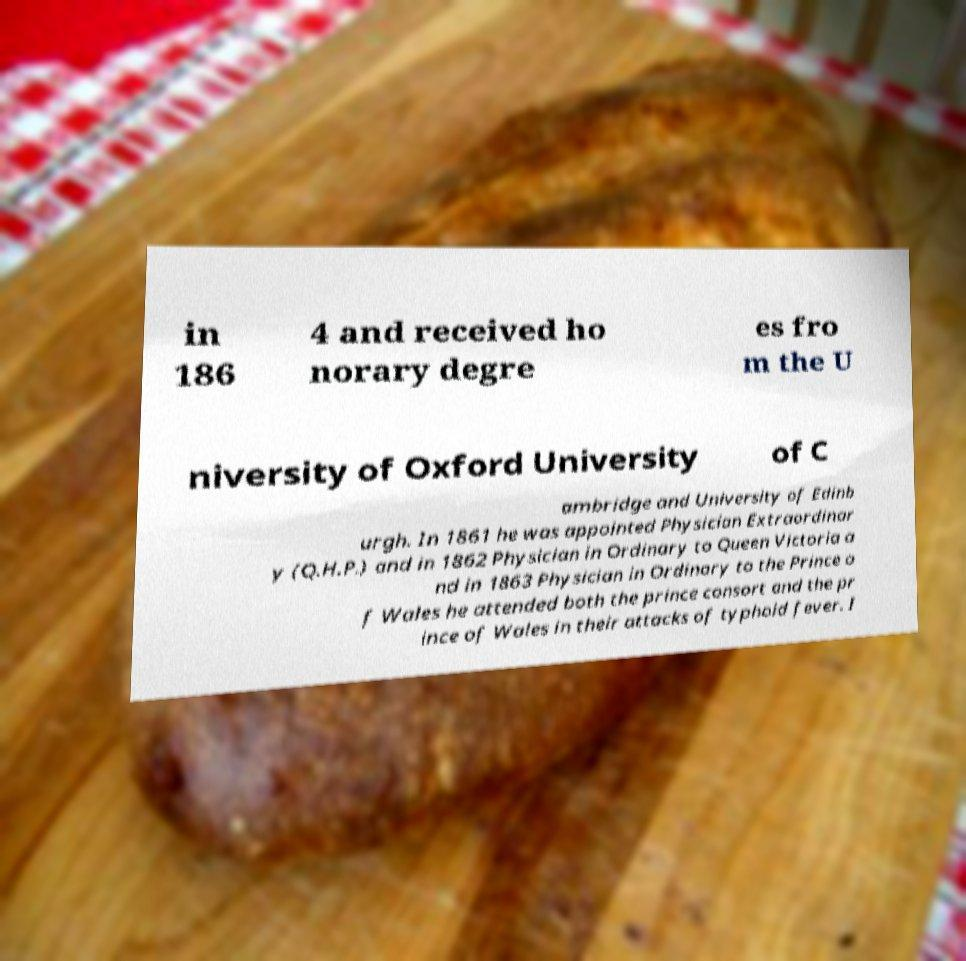What messages or text are displayed in this image? I need them in a readable, typed format. in 186 4 and received ho norary degre es fro m the U niversity of Oxford University of C ambridge and University of Edinb urgh. In 1861 he was appointed Physician Extraordinar y (Q.H.P.) and in 1862 Physician in Ordinary to Queen Victoria a nd in 1863 Physician in Ordinary to the Prince o f Wales he attended both the prince consort and the pr ince of Wales in their attacks of typhoid fever. I 